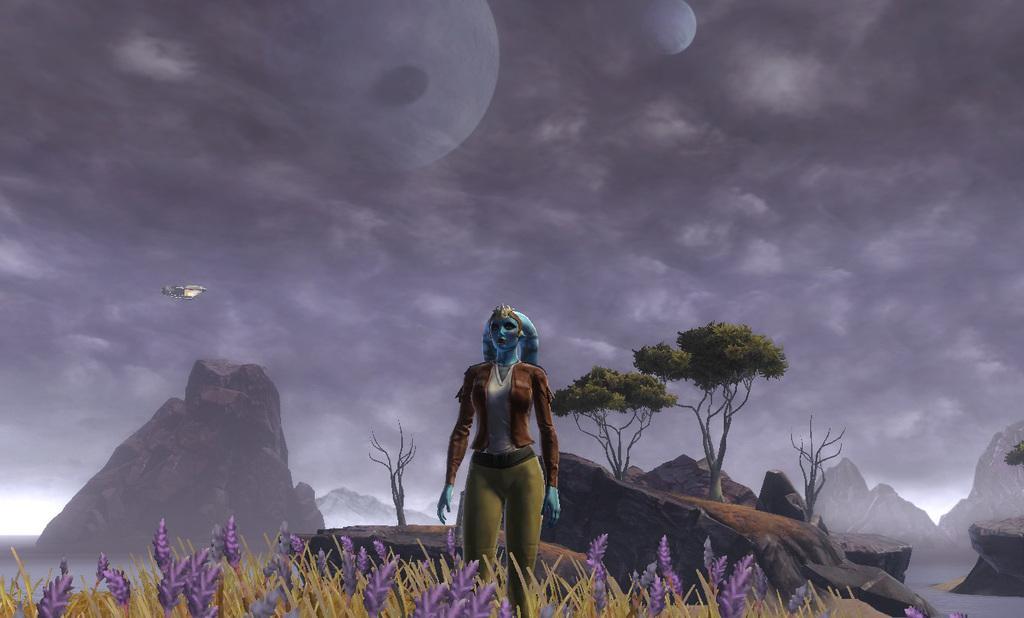Please provide a concise description of this image. In this image we can see the animated picture and there is a person standing and we can see some plants with flowers and trees. There are some rocks and we can see the mountains in the background and at the top we can see the sky and there is an object which looks like a space shuttle. 